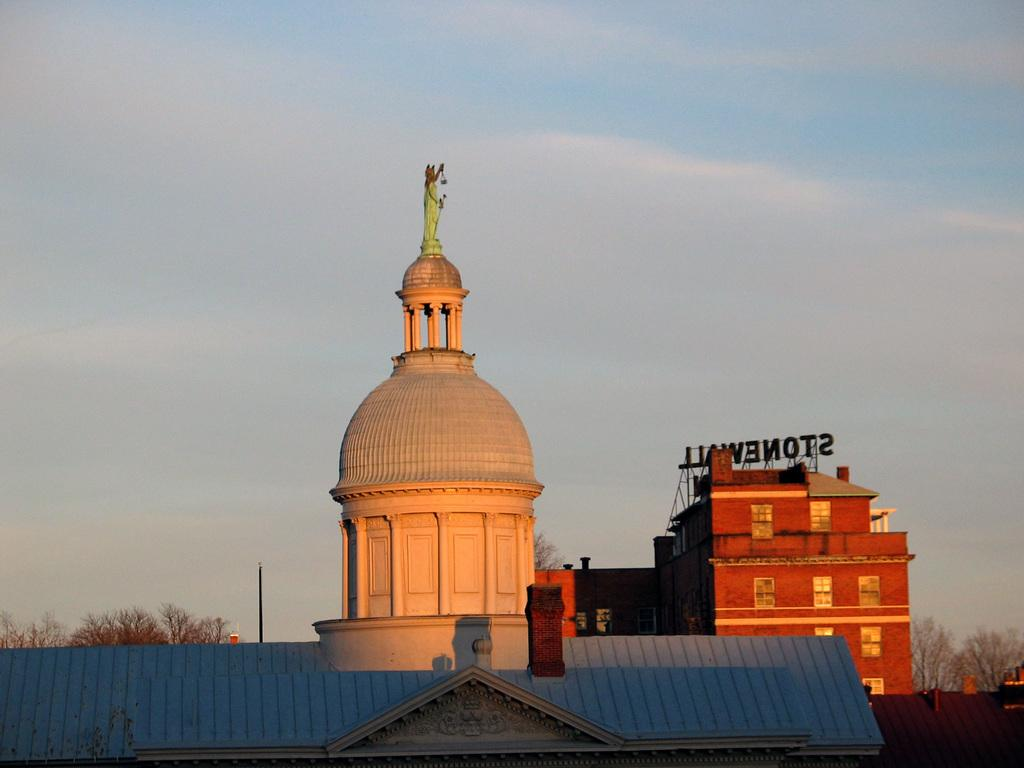What is located on top of the building in the image? There is a statue on top of the building in the image. What type of vegetation can be seen in the image? There are trees in the image. What object is present in the image that might be used for support or signage? There is a pole in the image. What can be seen in the sky in the image? There are clouds in the sky in the image. What middle idea does the statue represent in the image? The statue does not represent a middle idea in the image; it is a standalone object on top of the building. 